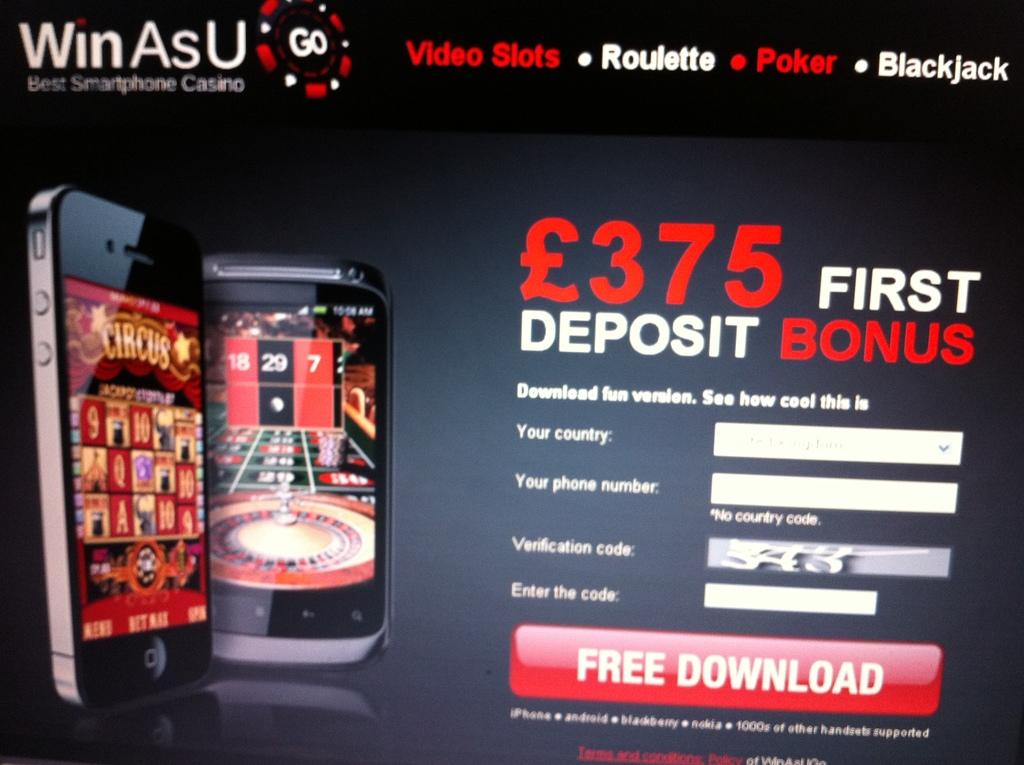How much is the first deposit bonus?
Make the answer very short. 375. What is the name of the app?
Your answer should be compact. Winasu. 